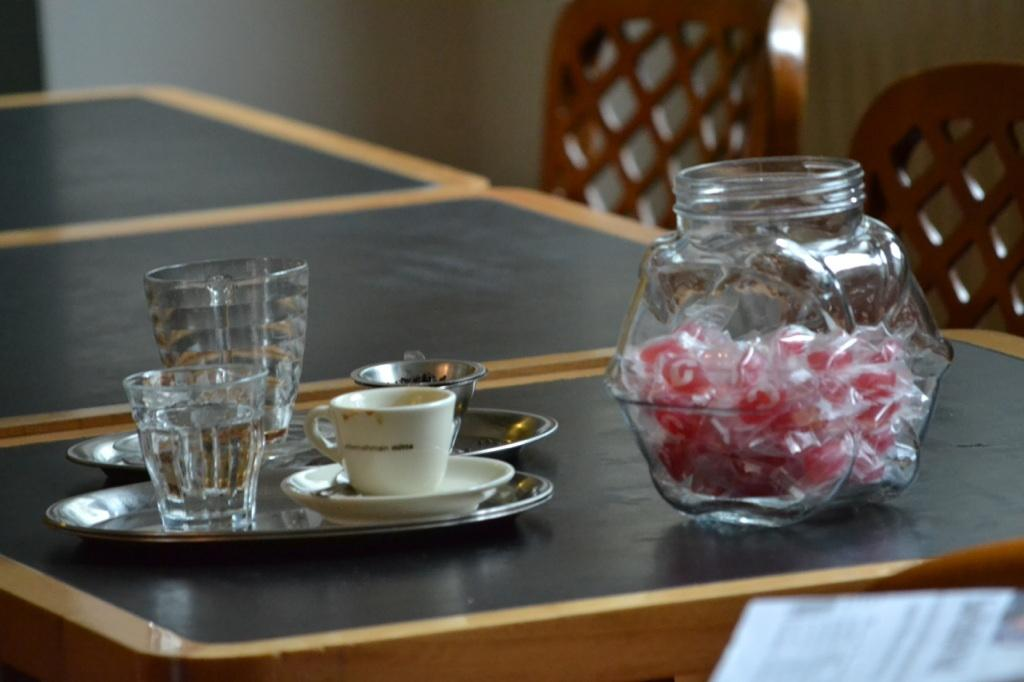What is the main piece of furniture in the image? There is a table in the image. What items are placed on the table? Cups, saucers, glasses, and jars are placed on the table. What can be seen in the background of the image? There are chairs and a wall in the background of the image. What type of design is featured on the shoes in the image? There are no shoes present in the image. How many bags of popcorn are visible on the table in the image? There are no bags of popcorn present in the image. 